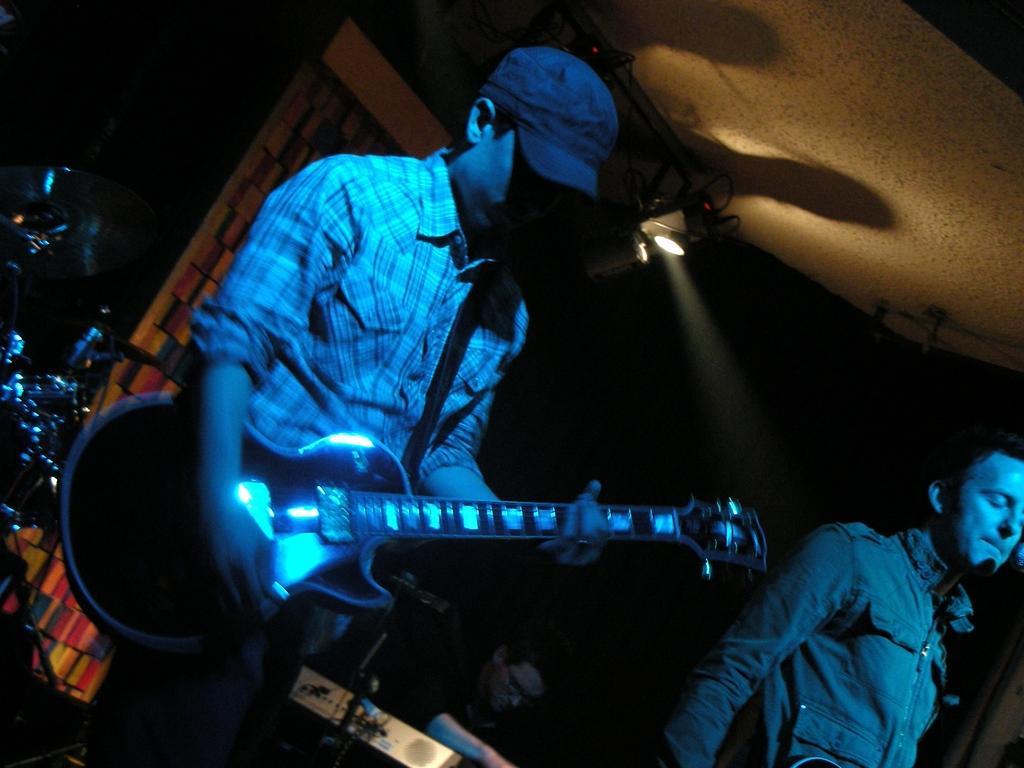In one or two sentences, can you explain what this image depicts? In a picture there are three people and coming to the right corner of the picture one person is standing and holding a guitar and wearing a cap and shirt and in the right corner of the picture one person is standing and behind them one person is sitting and beside him there are drums and wall and lights upon them and the background is dark. 